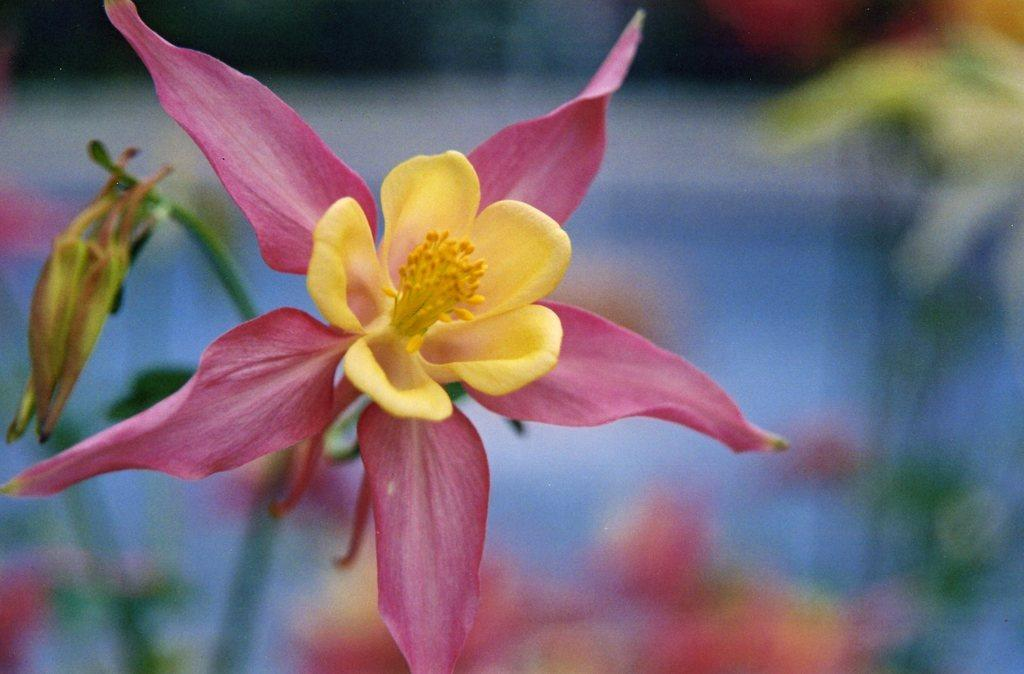What is the main subject in the center of the image? There is a flower in the center of the image, and there is also a bud. Can you describe the background of the image? The background of the image is blurry. What type of coat is hanging on the lamp in the image? There is no coat or lamp present in the image; it features a flower and a bud with a blurry background. 